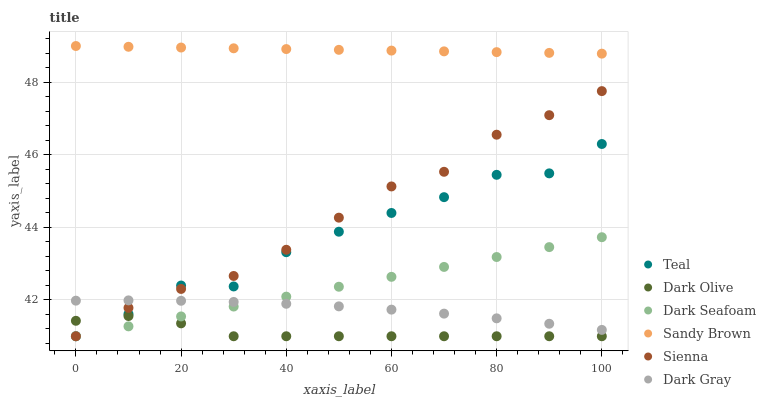Does Dark Olive have the minimum area under the curve?
Answer yes or no. Yes. Does Sandy Brown have the maximum area under the curve?
Answer yes or no. Yes. Does Sienna have the minimum area under the curve?
Answer yes or no. No. Does Sienna have the maximum area under the curve?
Answer yes or no. No. Is Sandy Brown the smoothest?
Answer yes or no. Yes. Is Teal the roughest?
Answer yes or no. Yes. Is Dark Olive the smoothest?
Answer yes or no. No. Is Dark Olive the roughest?
Answer yes or no. No. Does Dark Olive have the lowest value?
Answer yes or no. Yes. Does Sandy Brown have the lowest value?
Answer yes or no. No. Does Sandy Brown have the highest value?
Answer yes or no. Yes. Does Sienna have the highest value?
Answer yes or no. No. Is Sienna less than Sandy Brown?
Answer yes or no. Yes. Is Sandy Brown greater than Dark Gray?
Answer yes or no. Yes. Does Teal intersect Sienna?
Answer yes or no. Yes. Is Teal less than Sienna?
Answer yes or no. No. Is Teal greater than Sienna?
Answer yes or no. No. Does Sienna intersect Sandy Brown?
Answer yes or no. No. 